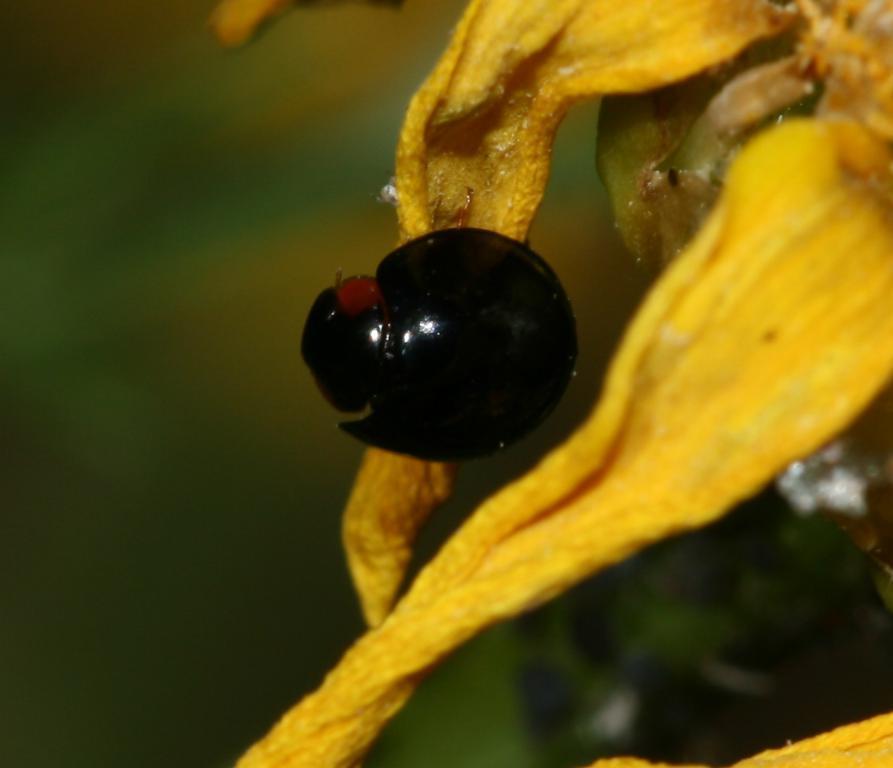Could you give a brief overview of what you see in this image? In this image I can see on the right side there are petals of the flower in yellow color. In the middle it looks like an insect in black color. 